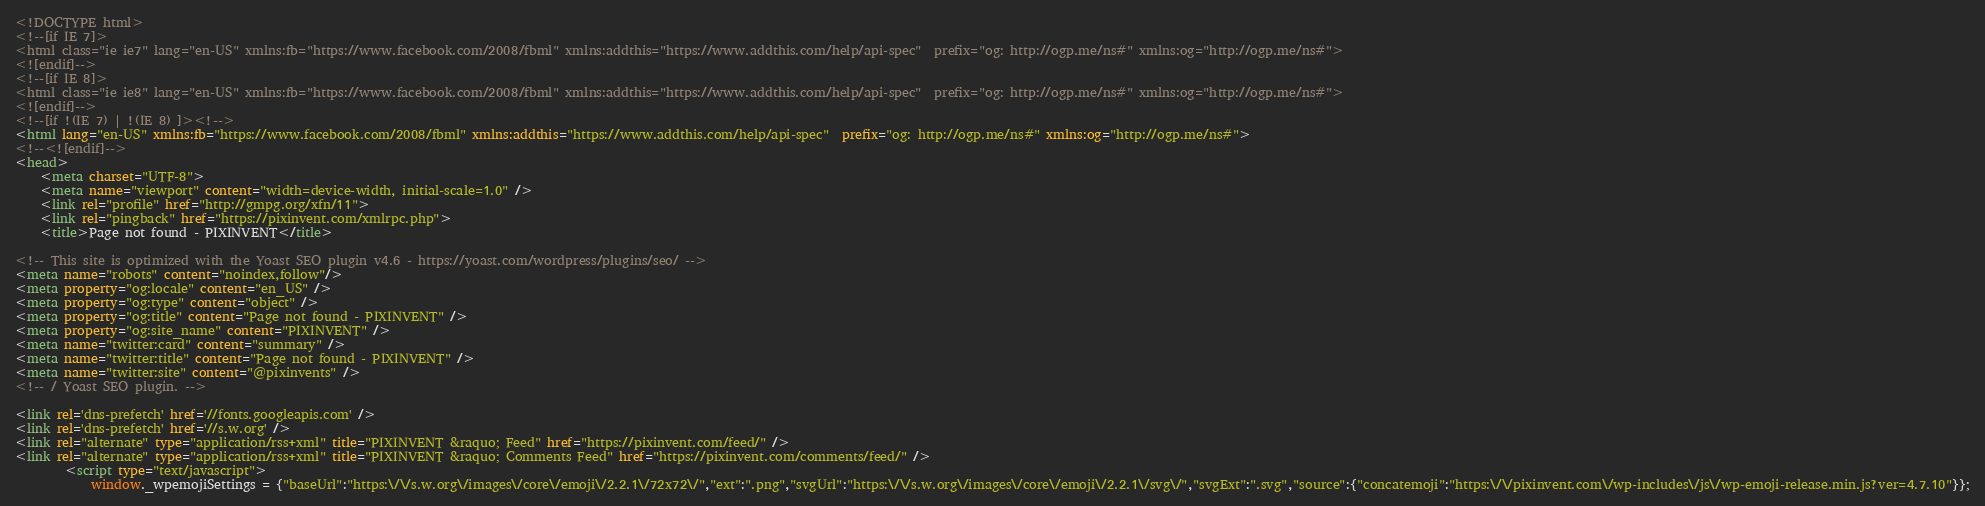Convert code to text. <code><loc_0><loc_0><loc_500><loc_500><_HTML_>
<!DOCTYPE html>
<!--[if IE 7]>
<html class="ie ie7" lang="en-US" xmlns:fb="https://www.facebook.com/2008/fbml" xmlns:addthis="https://www.addthis.com/help/api-spec"  prefix="og: http://ogp.me/ns#" xmlns:og="http://ogp.me/ns#">
<![endif]-->
<!--[if IE 8]>
<html class="ie ie8" lang="en-US" xmlns:fb="https://www.facebook.com/2008/fbml" xmlns:addthis="https://www.addthis.com/help/api-spec"  prefix="og: http://ogp.me/ns#" xmlns:og="http://ogp.me/ns#">
<![endif]-->
<!--[if !(IE 7) | !(IE 8) ]><!-->
<html lang="en-US" xmlns:fb="https://www.facebook.com/2008/fbml" xmlns:addthis="https://www.addthis.com/help/api-spec"  prefix="og: http://ogp.me/ns#" xmlns:og="http://ogp.me/ns#">
<!--<![endif]-->
<head>
	<meta charset="UTF-8">
	<meta name="viewport" content="width=device-width, initial-scale=1.0" />
	<link rel="profile" href="http://gmpg.org/xfn/11">
	<link rel="pingback" href="https://pixinvent.com/xmlrpc.php">
	<title>Page not found - PIXINVENT</title>

<!-- This site is optimized with the Yoast SEO plugin v4.6 - https://yoast.com/wordpress/plugins/seo/ -->
<meta name="robots" content="noindex,follow"/>
<meta property="og:locale" content="en_US" />
<meta property="og:type" content="object" />
<meta property="og:title" content="Page not found - PIXINVENT" />
<meta property="og:site_name" content="PIXINVENT" />
<meta name="twitter:card" content="summary" />
<meta name="twitter:title" content="Page not found - PIXINVENT" />
<meta name="twitter:site" content="@pixinvents" />
<!-- / Yoast SEO plugin. -->

<link rel='dns-prefetch' href='//fonts.googleapis.com' />
<link rel='dns-prefetch' href='//s.w.org' />
<link rel="alternate" type="application/rss+xml" title="PIXINVENT &raquo; Feed" href="https://pixinvent.com/feed/" />
<link rel="alternate" type="application/rss+xml" title="PIXINVENT &raquo; Comments Feed" href="https://pixinvent.com/comments/feed/" />
		<script type="text/javascript">
			window._wpemojiSettings = {"baseUrl":"https:\/\/s.w.org\/images\/core\/emoji\/2.2.1\/72x72\/","ext":".png","svgUrl":"https:\/\/s.w.org\/images\/core\/emoji\/2.2.1\/svg\/","svgExt":".svg","source":{"concatemoji":"https:\/\/pixinvent.com\/wp-includes\/js\/wp-emoji-release.min.js?ver=4.7.10"}};</code> 